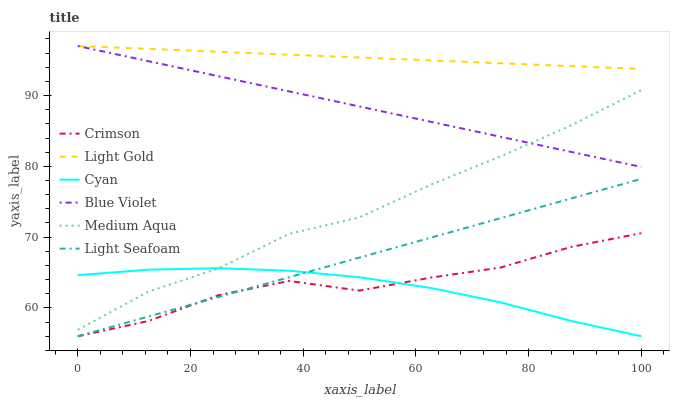Does Cyan have the minimum area under the curve?
Answer yes or no. Yes. Does Light Gold have the maximum area under the curve?
Answer yes or no. Yes. Does Crimson have the minimum area under the curve?
Answer yes or no. No. Does Crimson have the maximum area under the curve?
Answer yes or no. No. Is Light Seafoam the smoothest?
Answer yes or no. Yes. Is Crimson the roughest?
Answer yes or no. Yes. Is Cyan the smoothest?
Answer yes or no. No. Is Cyan the roughest?
Answer yes or no. No. Does Light Gold have the lowest value?
Answer yes or no. No. Does Blue Violet have the highest value?
Answer yes or no. Yes. Does Crimson have the highest value?
Answer yes or no. No. Is Crimson less than Light Gold?
Answer yes or no. Yes. Is Light Gold greater than Light Seafoam?
Answer yes or no. Yes. Does Crimson intersect Light Gold?
Answer yes or no. No. 